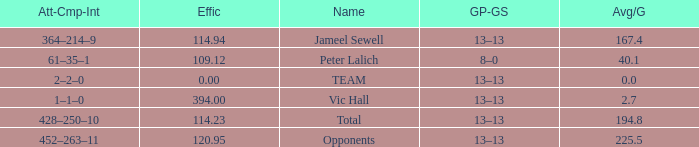Avg/G of 2.7 is what effic? 394.0. 